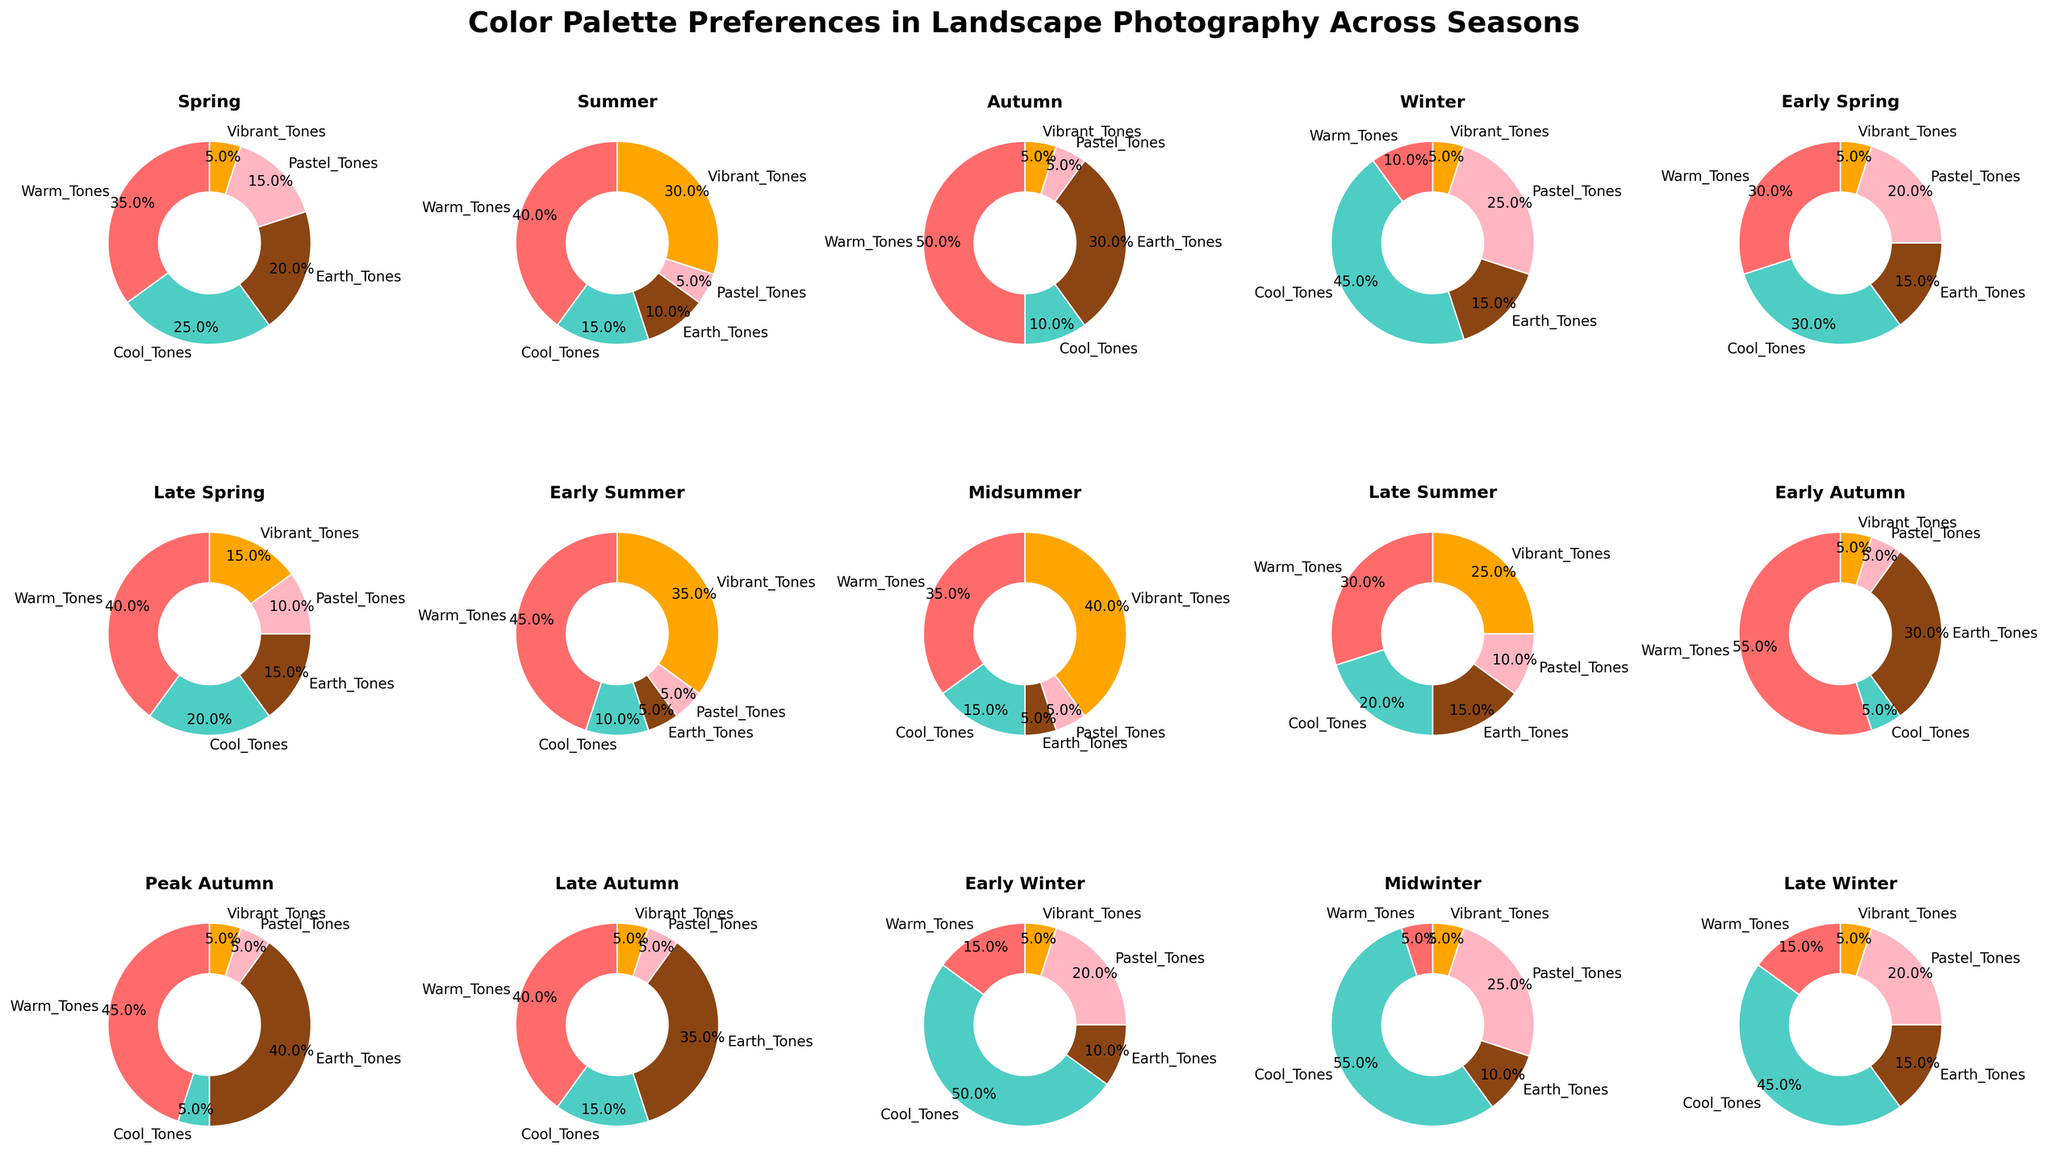What's the most dominant color tone in the autumn seasons? First, identify the autumn seasons: Early Autumn, Peak Autumn, and Late Autumn. Then, look at the pie charts for these seasons and compare the color tone with the largest percentages. The dominant color tone appears to be warm tones in all three autumn seasons.
Answer: Warm Tones Which season has the highest percent of cool tones? Analyze each pie chart and compare the percentages associated with cool tones. Winter and Midwinter show high percentages for cool tones, but Midwinter has the highest at 55%.
Answer: Midwinter What is the least preferred color tone in summer seasons? Identify the summer seasons: Early Summer, Midsummer, and Late Summer. Look for the tone with the smallest percentage in these seasons' pie charts. Earth tones consistently show the smallest values across the three summer plots.
Answer: Earth Tones How does the preference for pastel tones change from early to late spring? Compare the percentage of pastel tones between Early Spring and Late Spring pie charts. Early Spring has 20%, whereas Late Spring has 10%, indicating a decrease.
Answer: Decreases Which season shows an equal preference for warm and cool tones? Scan the pie charts to find a season where the percentages for warm and cool tones are the same. Early Spring season has 30% for both warm and cool tones.
Answer: Early Spring In which seasons do vibrant tones gain increasing preference? Focus on the pie charts for multiple seasons and identify the trend seen in increasing percentages for vibrant tones. These percentages increase from Early Summer (35%) to Midsummer (40%).
Answer: Early Summer, Midsummer Which tone is the least preferred overall, and in which seasons does this occur? Look for the smallest percentages among all tones across all seasons. Vibrant tones have minimal representation (5% or less) in several seasons: Spring, Early Spring, Early Autumn, Peak Autumn, Late Autumn, and Early Winter.
Answer: Vibrant Tones, Multiple Seasons What is the total preference percentage for earth tones across all the autumn seasons? Sum the percentages for Earth Tones from Early Autumn, Peak Autumn, and Late Autumn: 30% + 40% + 35% = 105%.
Answer: 105% Is there a season where warm tones have the same preference as the sum of pastel and vibrant tones? Compare pie charts where the percentage of warm tones equals the sum of pastel and vibrant tones. In Early Winter, warm tones (15%) equal the sum of pastel tones (20%) and vibrant tones (5%), which totals 25%.
Answer: Early Winter Which season has the most balanced distribution of all five color tones? Analyze pie charts to identify a season where the color tone percentages are closest in value. Spring has a relatively balanced distribution among all tones (35%, 25%, 20%, 15%, 5%).
Answer: Spring 